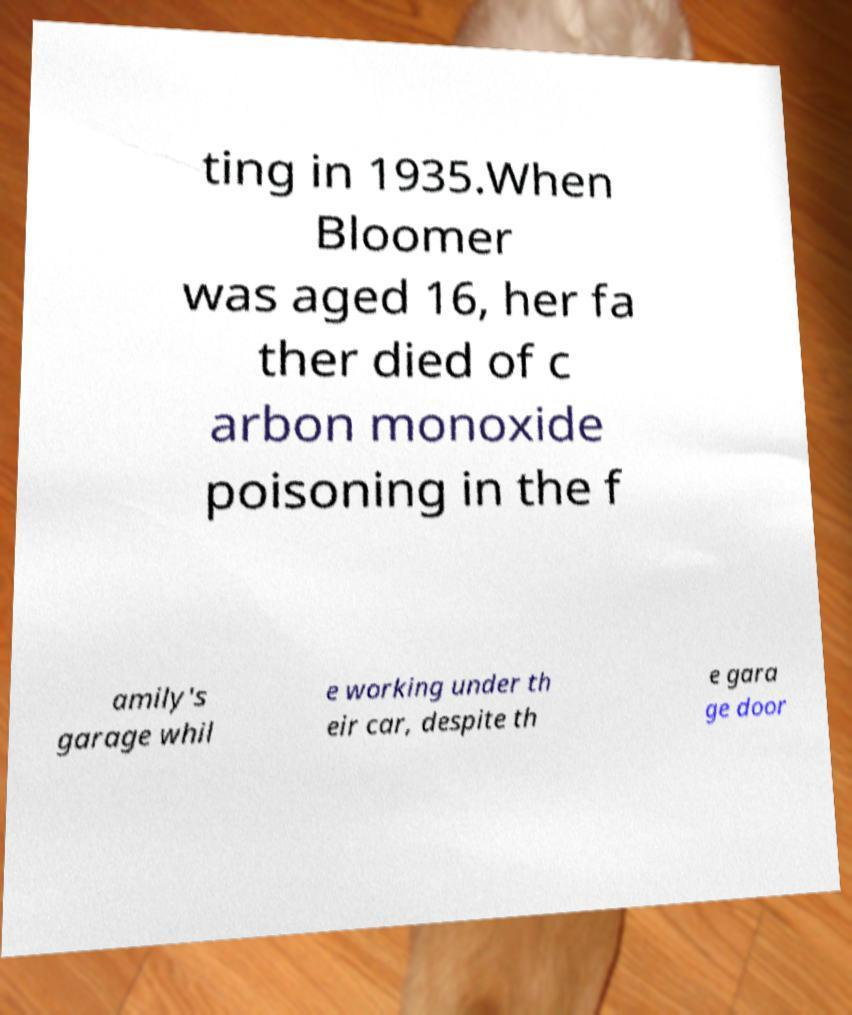Could you extract and type out the text from this image? ting in 1935.When Bloomer was aged 16, her fa ther died of c arbon monoxide poisoning in the f amily's garage whil e working under th eir car, despite th e gara ge door 